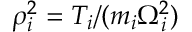Convert formula to latex. <formula><loc_0><loc_0><loc_500><loc_500>\rho _ { i } ^ { 2 } = T _ { i } / ( m _ { i } \Omega _ { i } ^ { 2 } )</formula> 